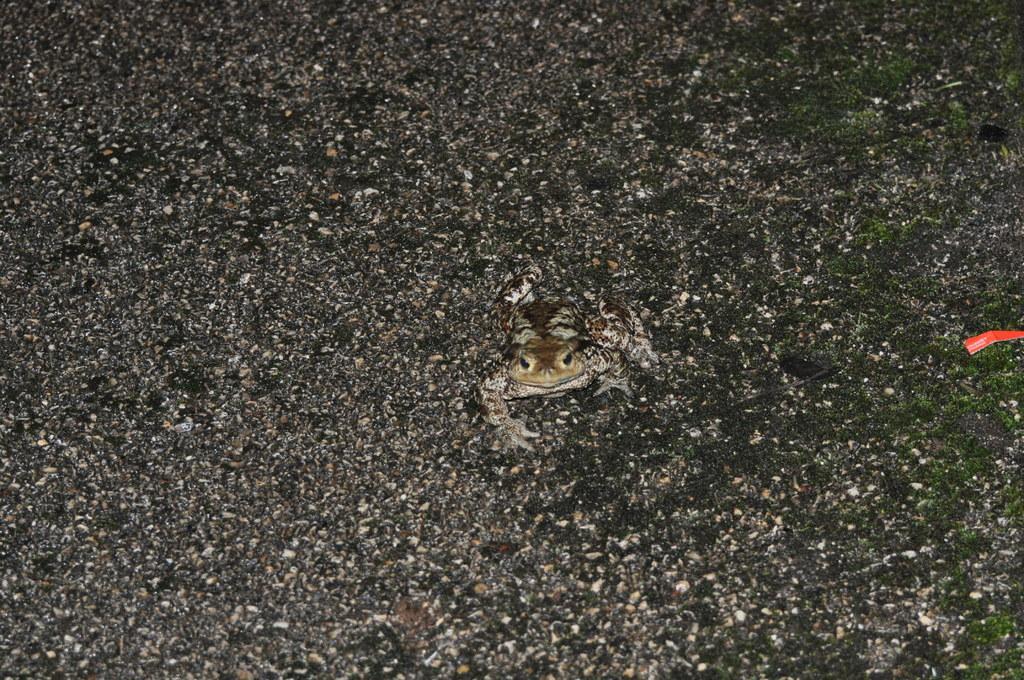In one or two sentences, can you explain what this image depicts? In this picture we can see the eastern spadefoot in the middle, at the bottom there are some stones and grass. 